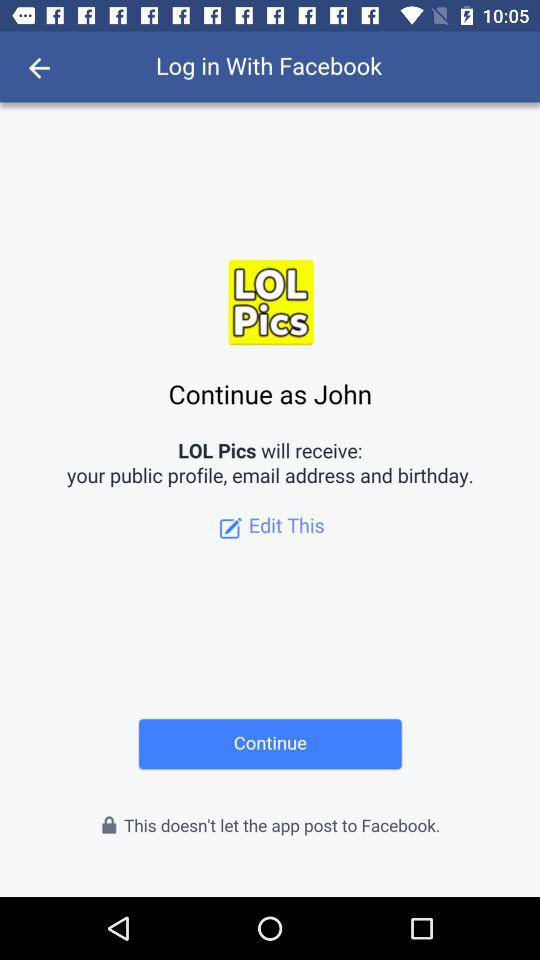What is the user name? The user name is John. 